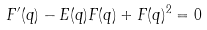Convert formula to latex. <formula><loc_0><loc_0><loc_500><loc_500>F ^ { \prime } ( q ) - E ( q ) F ( q ) + F ( q ) ^ { 2 } = 0</formula> 